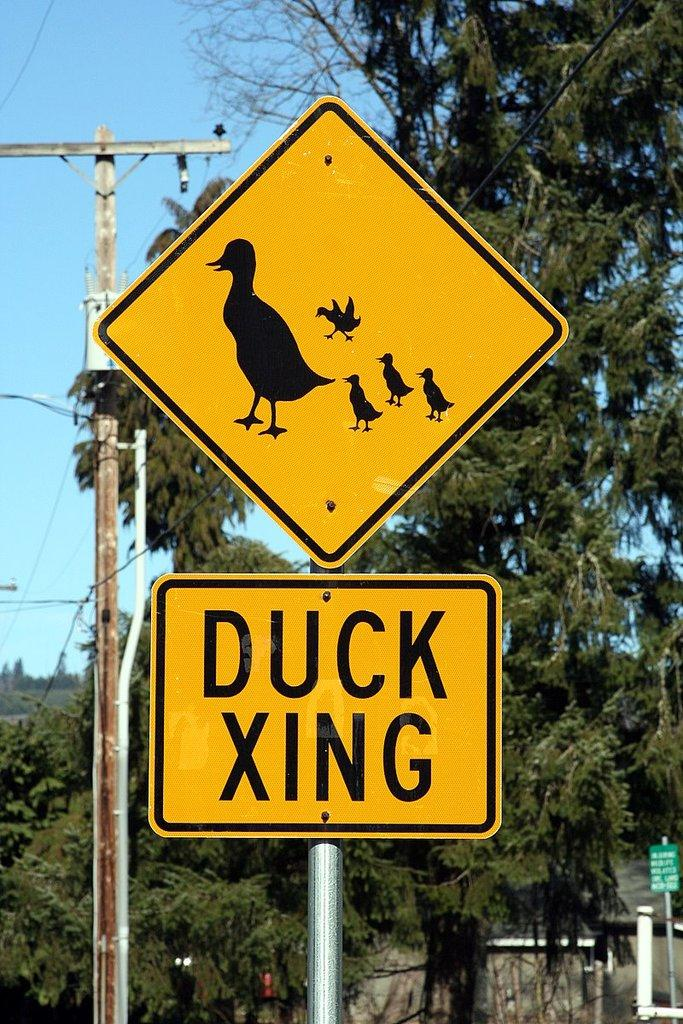<image>
Give a short and clear explanation of the subsequent image. A yellow sign warns of ducks xing on a street. 